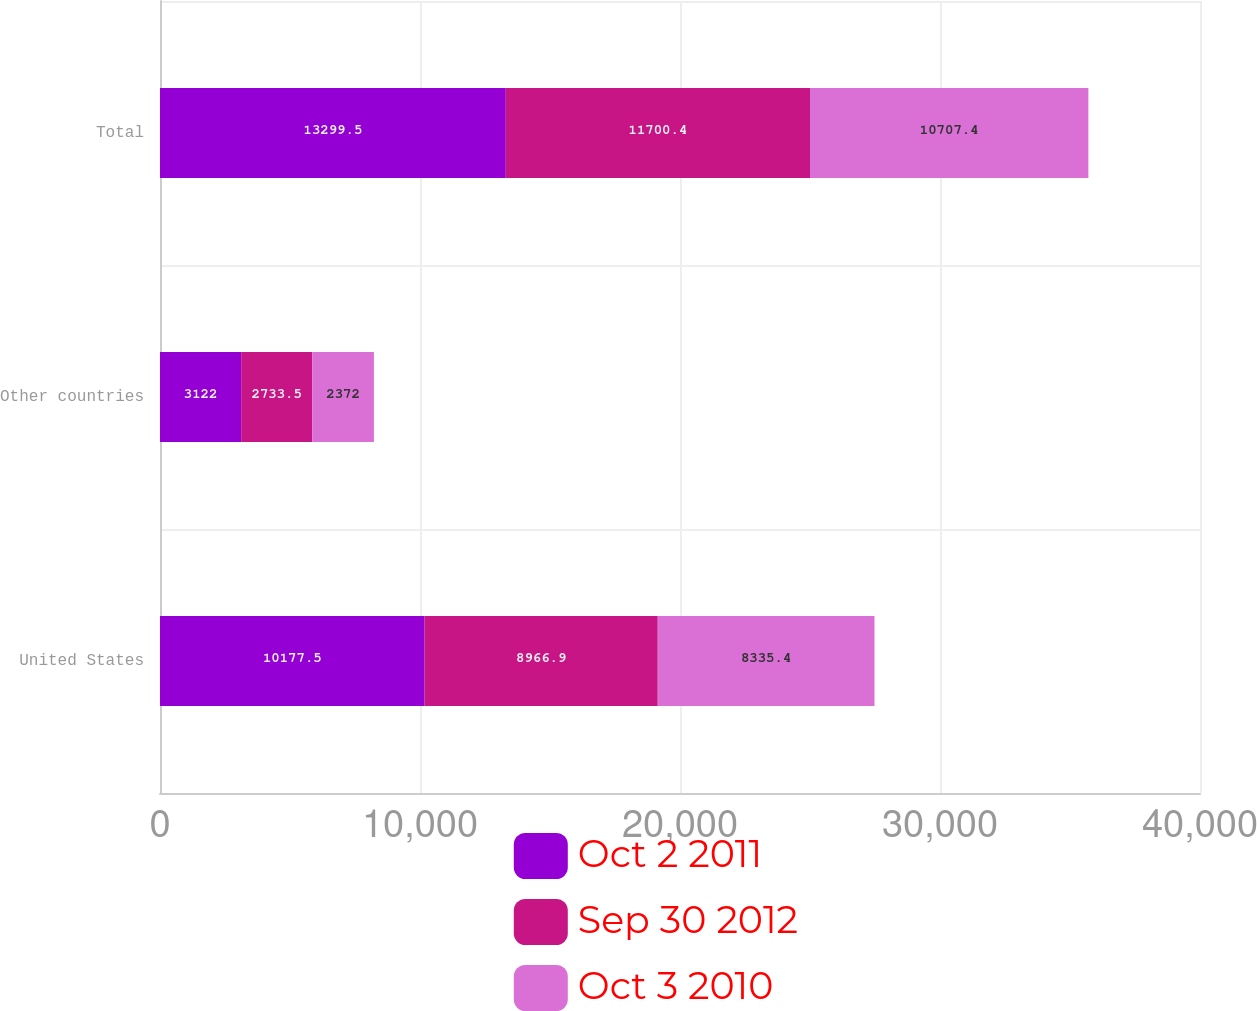Convert chart to OTSL. <chart><loc_0><loc_0><loc_500><loc_500><stacked_bar_chart><ecel><fcel>United States<fcel>Other countries<fcel>Total<nl><fcel>Oct 2 2011<fcel>10177.5<fcel>3122<fcel>13299.5<nl><fcel>Sep 30 2012<fcel>8966.9<fcel>2733.5<fcel>11700.4<nl><fcel>Oct 3 2010<fcel>8335.4<fcel>2372<fcel>10707.4<nl></chart> 